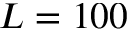Convert formula to latex. <formula><loc_0><loc_0><loc_500><loc_500>L = 1 0 0</formula> 